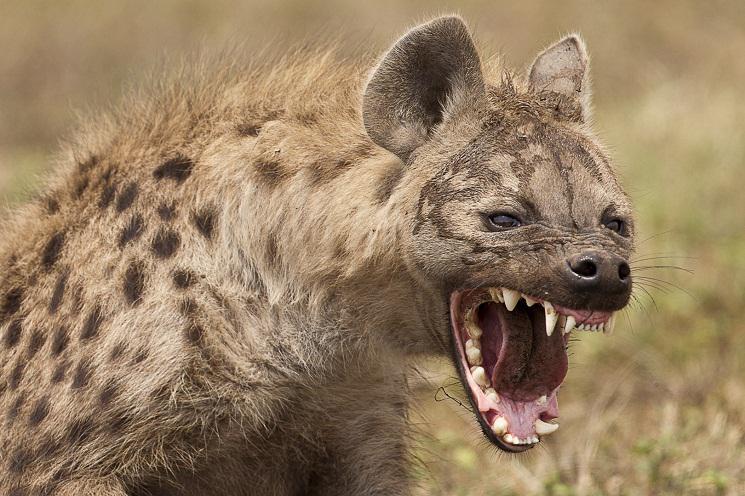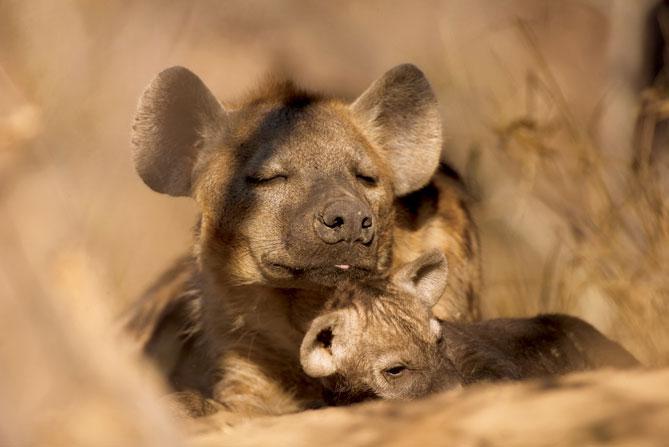The first image is the image on the left, the second image is the image on the right. Evaluate the accuracy of this statement regarding the images: "An image shows an adult hyena lying with a much younger hyena.". Is it true? Answer yes or no. Yes. The first image is the image on the left, the second image is the image on the right. Analyze the images presented: Is the assertion "There are hyena cubs laying with their moms" valid? Answer yes or no. Yes. 